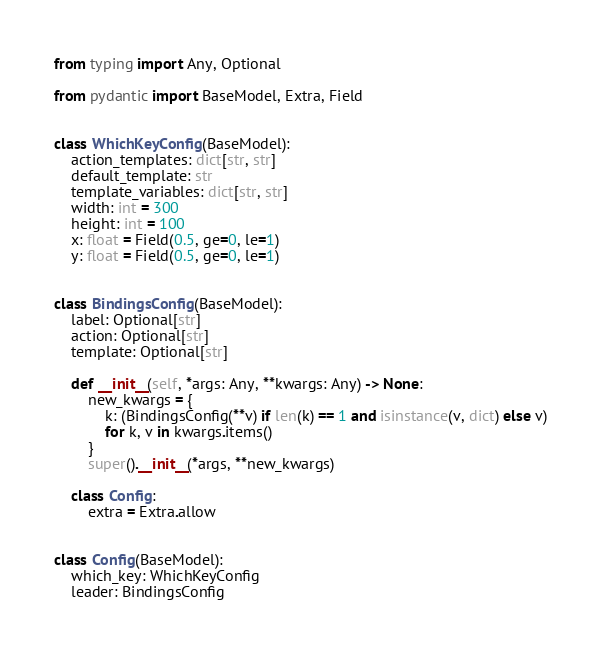<code> <loc_0><loc_0><loc_500><loc_500><_Python_>from typing import Any, Optional

from pydantic import BaseModel, Extra, Field


class WhichKeyConfig(BaseModel):
    action_templates: dict[str, str]
    default_template: str
    template_variables: dict[str, str]
    width: int = 300
    height: int = 100
    x: float = Field(0.5, ge=0, le=1)
    y: float = Field(0.5, ge=0, le=1)


class BindingsConfig(BaseModel):
    label: Optional[str]
    action: Optional[str]
    template: Optional[str]

    def __init__(self, *args: Any, **kwargs: Any) -> None:
        new_kwargs = {
            k: (BindingsConfig(**v) if len(k) == 1 and isinstance(v, dict) else v)
            for k, v in kwargs.items()
        }
        super().__init__(*args, **new_kwargs)

    class Config:
        extra = Extra.allow


class Config(BaseModel):
    which_key: WhichKeyConfig
    leader: BindingsConfig
</code> 